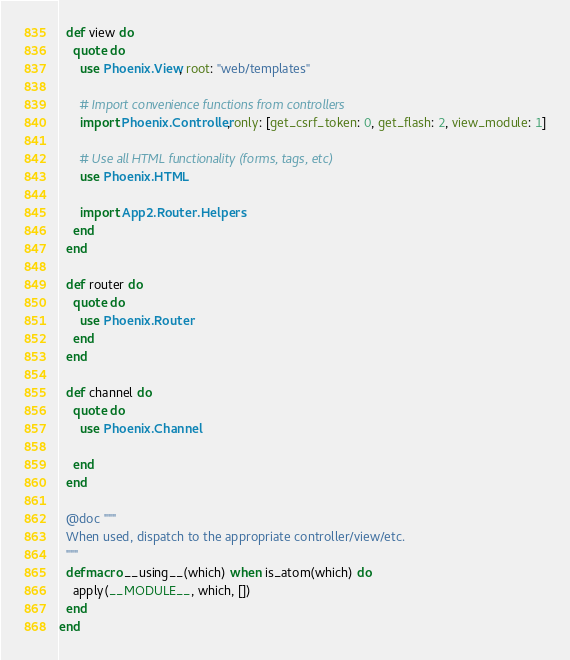<code> <loc_0><loc_0><loc_500><loc_500><_Elixir_>  def view do
    quote do
      use Phoenix.View, root: "web/templates"

      # Import convenience functions from controllers
      import Phoenix.Controller, only: [get_csrf_token: 0, get_flash: 2, view_module: 1]

      # Use all HTML functionality (forms, tags, etc)
      use Phoenix.HTML

      import App2.Router.Helpers
    end
  end

  def router do
    quote do
      use Phoenix.Router
    end
  end

  def channel do
    quote do
      use Phoenix.Channel

    end
  end

  @doc """
  When used, dispatch to the appropriate controller/view/etc.
  """
  defmacro __using__(which) when is_atom(which) do
    apply(__MODULE__, which, [])
  end
end
</code> 